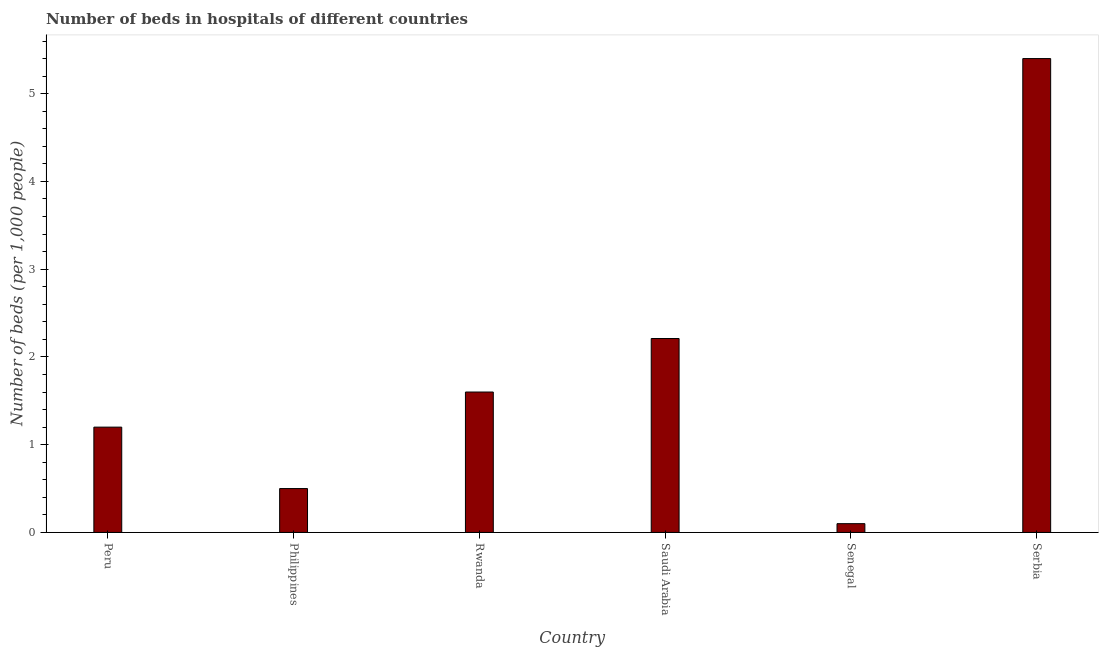Does the graph contain any zero values?
Ensure brevity in your answer.  No. Does the graph contain grids?
Your answer should be compact. No. What is the title of the graph?
Your response must be concise. Number of beds in hospitals of different countries. What is the label or title of the X-axis?
Keep it short and to the point. Country. What is the label or title of the Y-axis?
Ensure brevity in your answer.  Number of beds (per 1,0 people). What is the number of hospital beds in Peru?
Keep it short and to the point. 1.2. Across all countries, what is the minimum number of hospital beds?
Make the answer very short. 0.1. In which country was the number of hospital beds maximum?
Offer a very short reply. Serbia. In which country was the number of hospital beds minimum?
Make the answer very short. Senegal. What is the sum of the number of hospital beds?
Offer a very short reply. 11.01. What is the difference between the number of hospital beds in Peru and Rwanda?
Keep it short and to the point. -0.4. What is the average number of hospital beds per country?
Offer a terse response. 1.83. In how many countries, is the number of hospital beds greater than 4.4 %?
Your response must be concise. 1. What is the ratio of the number of hospital beds in Peru to that in Philippines?
Provide a short and direct response. 2.4. Is the number of hospital beds in Philippines less than that in Rwanda?
Provide a short and direct response. Yes. Is the difference between the number of hospital beds in Saudi Arabia and Serbia greater than the difference between any two countries?
Give a very brief answer. No. What is the difference between the highest and the second highest number of hospital beds?
Your response must be concise. 3.19. Is the sum of the number of hospital beds in Peru and Philippines greater than the maximum number of hospital beds across all countries?
Offer a terse response. No. What is the difference between the highest and the lowest number of hospital beds?
Keep it short and to the point. 5.3. In how many countries, is the number of hospital beds greater than the average number of hospital beds taken over all countries?
Make the answer very short. 2. How many bars are there?
Offer a terse response. 6. Are all the bars in the graph horizontal?
Offer a terse response. No. How many countries are there in the graph?
Keep it short and to the point. 6. Are the values on the major ticks of Y-axis written in scientific E-notation?
Provide a succinct answer. No. What is the Number of beds (per 1,000 people) of Saudi Arabia?
Offer a very short reply. 2.21. What is the Number of beds (per 1,000 people) of Serbia?
Ensure brevity in your answer.  5.4. What is the difference between the Number of beds (per 1,000 people) in Peru and Saudi Arabia?
Provide a short and direct response. -1.01. What is the difference between the Number of beds (per 1,000 people) in Philippines and Saudi Arabia?
Your answer should be very brief. -1.71. What is the difference between the Number of beds (per 1,000 people) in Philippines and Senegal?
Ensure brevity in your answer.  0.4. What is the difference between the Number of beds (per 1,000 people) in Philippines and Serbia?
Provide a short and direct response. -4.9. What is the difference between the Number of beds (per 1,000 people) in Rwanda and Saudi Arabia?
Your response must be concise. -0.61. What is the difference between the Number of beds (per 1,000 people) in Rwanda and Senegal?
Your response must be concise. 1.5. What is the difference between the Number of beds (per 1,000 people) in Rwanda and Serbia?
Your answer should be very brief. -3.8. What is the difference between the Number of beds (per 1,000 people) in Saudi Arabia and Senegal?
Your response must be concise. 2.11. What is the difference between the Number of beds (per 1,000 people) in Saudi Arabia and Serbia?
Ensure brevity in your answer.  -3.19. What is the difference between the Number of beds (per 1,000 people) in Senegal and Serbia?
Offer a very short reply. -5.3. What is the ratio of the Number of beds (per 1,000 people) in Peru to that in Philippines?
Make the answer very short. 2.4. What is the ratio of the Number of beds (per 1,000 people) in Peru to that in Saudi Arabia?
Ensure brevity in your answer.  0.54. What is the ratio of the Number of beds (per 1,000 people) in Peru to that in Serbia?
Your answer should be very brief. 0.22. What is the ratio of the Number of beds (per 1,000 people) in Philippines to that in Rwanda?
Keep it short and to the point. 0.31. What is the ratio of the Number of beds (per 1,000 people) in Philippines to that in Saudi Arabia?
Your answer should be compact. 0.23. What is the ratio of the Number of beds (per 1,000 people) in Philippines to that in Serbia?
Provide a short and direct response. 0.09. What is the ratio of the Number of beds (per 1,000 people) in Rwanda to that in Saudi Arabia?
Keep it short and to the point. 0.72. What is the ratio of the Number of beds (per 1,000 people) in Rwanda to that in Serbia?
Give a very brief answer. 0.3. What is the ratio of the Number of beds (per 1,000 people) in Saudi Arabia to that in Senegal?
Your response must be concise. 22.1. What is the ratio of the Number of beds (per 1,000 people) in Saudi Arabia to that in Serbia?
Provide a short and direct response. 0.41. What is the ratio of the Number of beds (per 1,000 people) in Senegal to that in Serbia?
Ensure brevity in your answer.  0.02. 